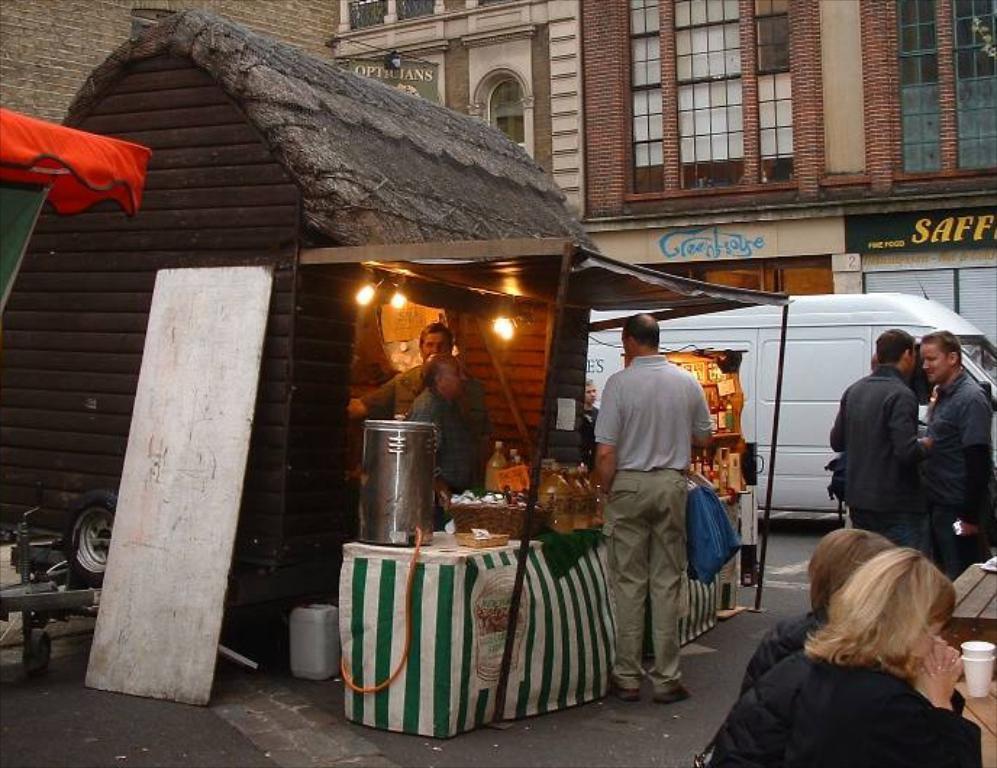Please provide a concise description of this image. This looks like a food stall. This is a table covered with a cloth. I can see a steel can, basket, bottles and few other things are placed on the table. These are the lights. I can see few people standing. This looks like a van, which is white in color. This is the building with windows. I can see the white color wooden board. There are two people sitting. This looks like a wooden table with paper cups on it. 